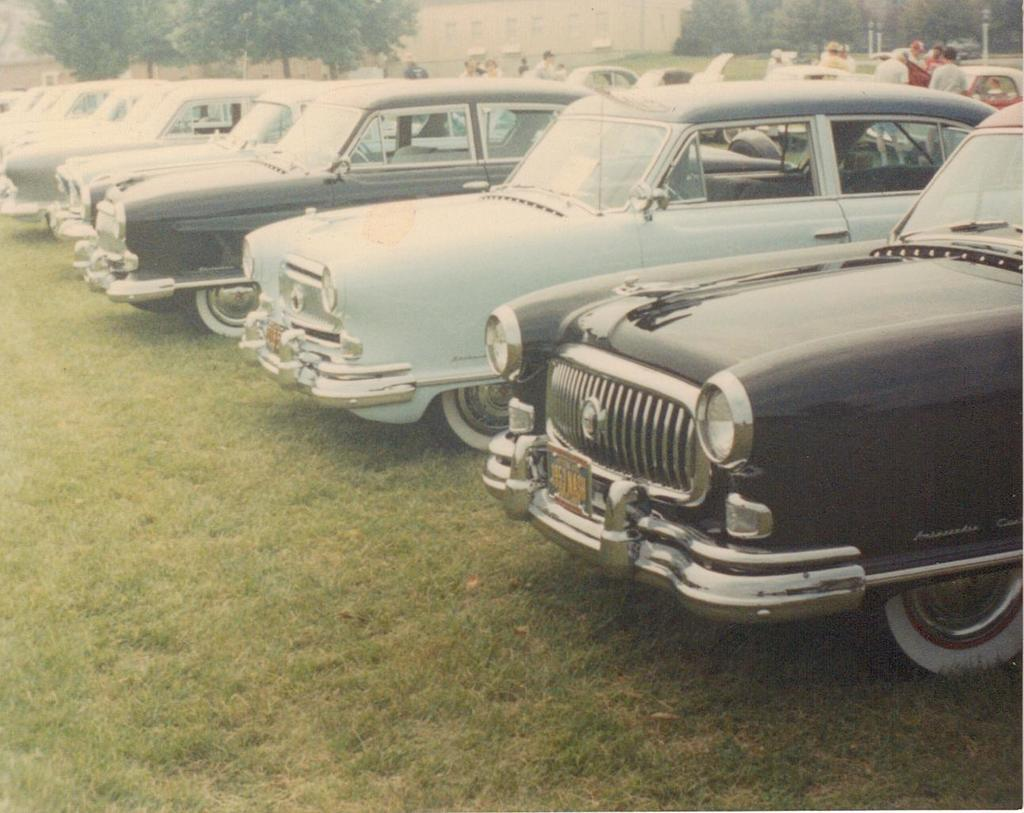What is located in the center of the image? There are vehicles parked in the center of the image. What can be seen in the background of the image? Buildings, trees, poles, grass, and people are present in the background of the image. Can you describe the setting of the image? The image shows vehicles parked in front of buildings, with trees, poles, grass, and people in the background. What type of coat is hanging in the cellar in the image? There is no cellar or coat present in the image. What scene is depicted in the image? The image shows vehicles parked in front of buildings, with trees, poles, grass, and people in the background. 